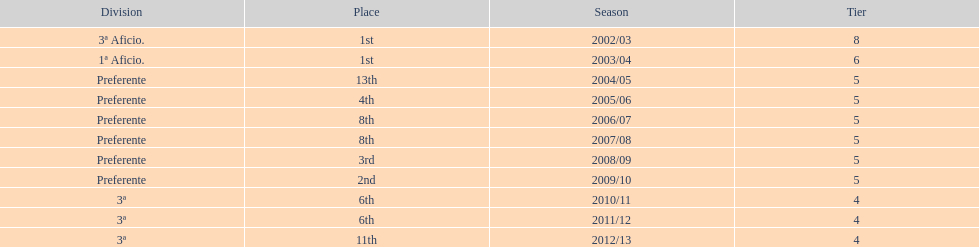How many times did  internacional de madrid cf come in 6th place? 6th, 6th. What is the first season that the team came in 6th place? 2010/11. Which season after the first did they place in 6th again? 2011/12. 